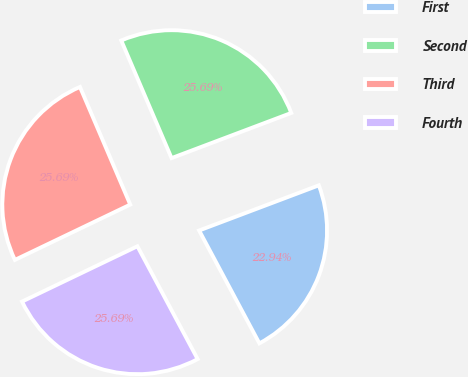Convert chart to OTSL. <chart><loc_0><loc_0><loc_500><loc_500><pie_chart><fcel>First<fcel>Second<fcel>Third<fcel>Fourth<nl><fcel>22.94%<fcel>25.69%<fcel>25.69%<fcel>25.69%<nl></chart> 